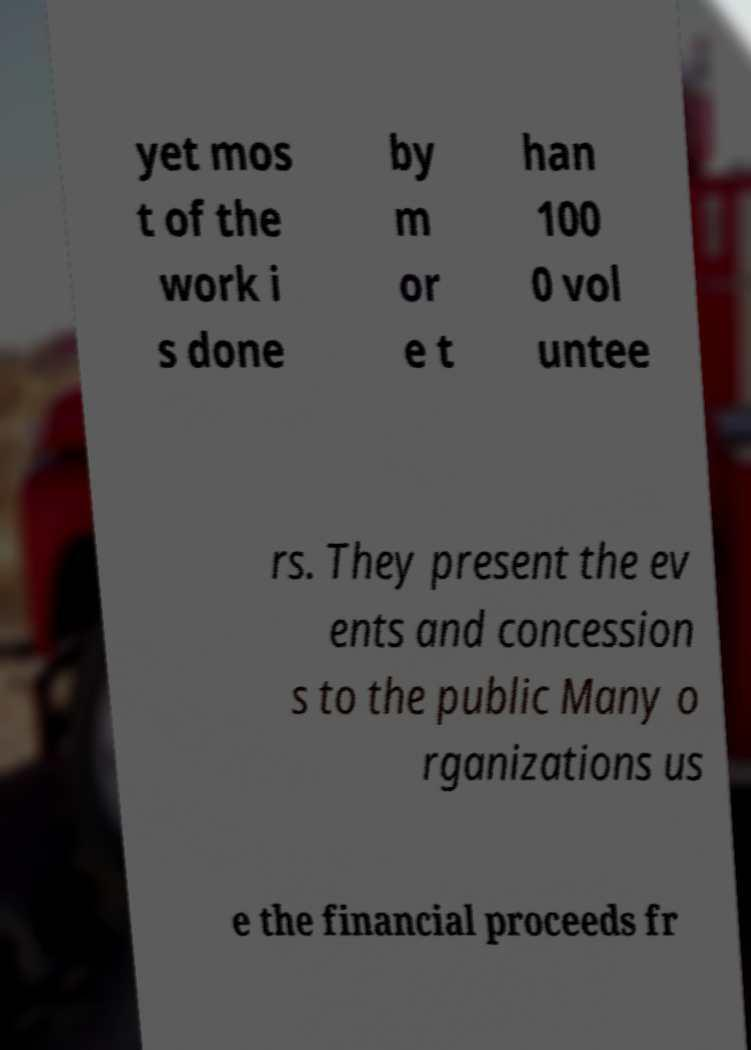What messages or text are displayed in this image? I need them in a readable, typed format. yet mos t of the work i s done by m or e t han 100 0 vol untee rs. They present the ev ents and concession s to the public Many o rganizations us e the financial proceeds fr 